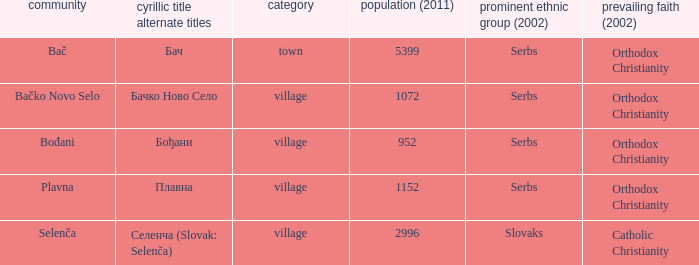What is the ethnic majority in the only town? Serbs. 